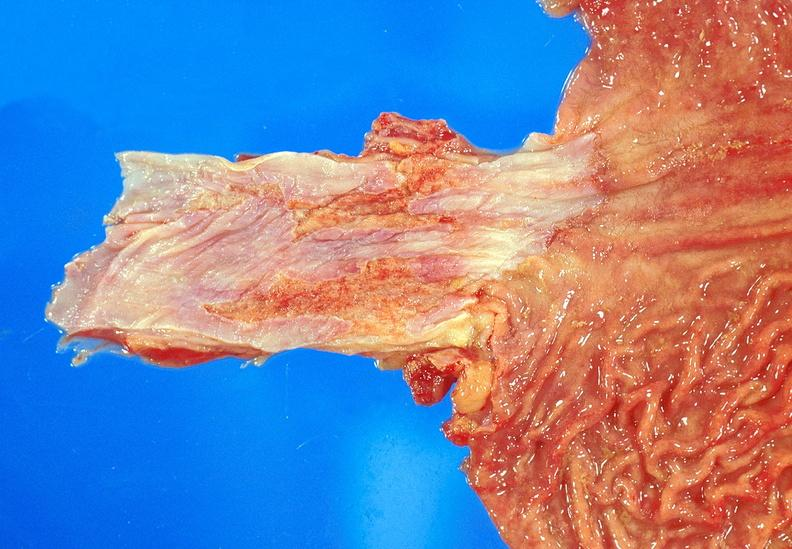does this image show barrett 's esophagus?
Answer the question using a single word or phrase. Yes 